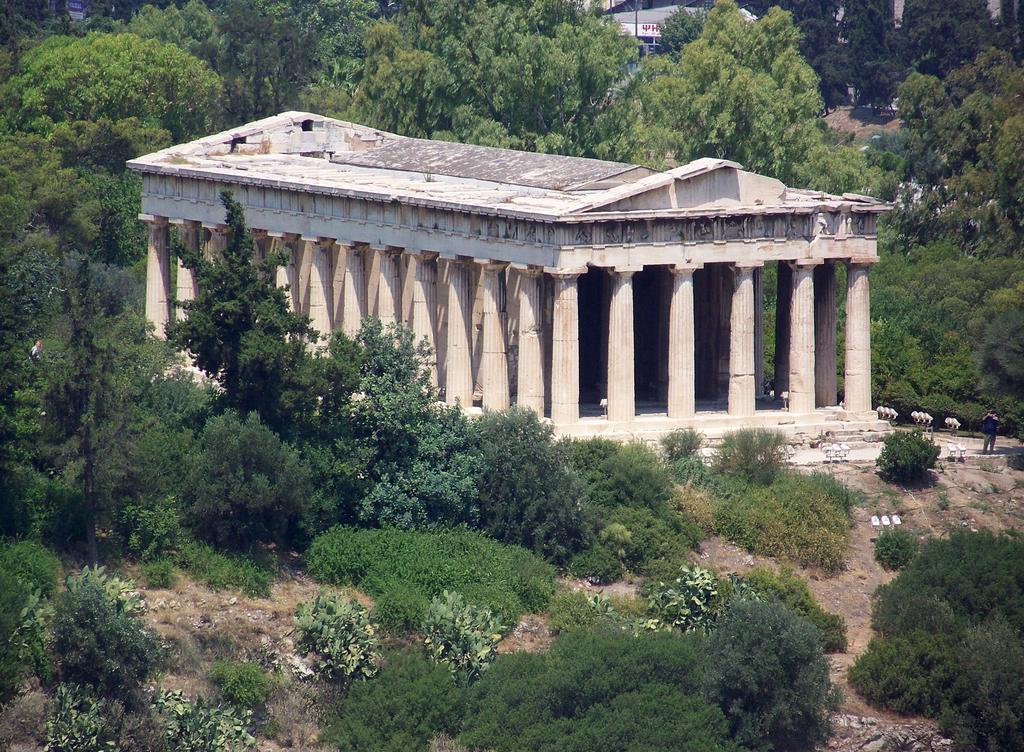What type of structure is visible in the image? There is a building with pillars in the image. What can be seen on the land at the bottom of the image? Plants are present on the land at the bottom of the image. What type of vegetation is visible at the top of the image? There are trees at the top of the image. What type of patch can be seen on the nose of the building in the image? There is no patch on the nose of the building, as buildings do not have noses. 